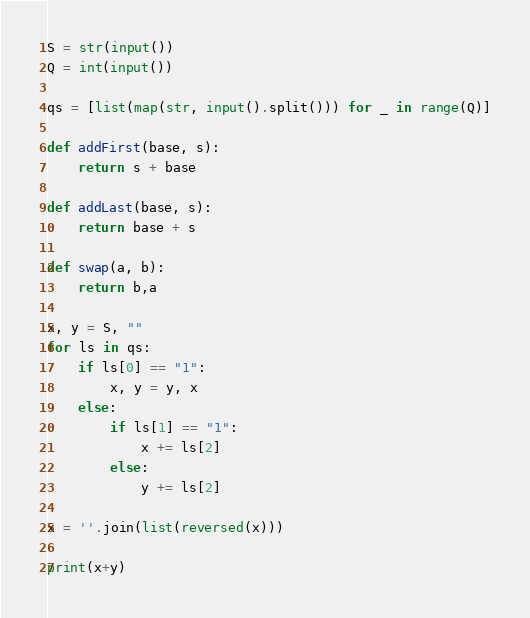<code> <loc_0><loc_0><loc_500><loc_500><_Python_>S = str(input())
Q = int(input())

qs = [list(map(str, input().split())) for _ in range(Q)]

def addFirst(base, s):
    return s + base

def addLast(base, s):
    return base + s

def swap(a, b):
    return b,a

x, y = S, ""
for ls in qs:
    if ls[0] == "1":
        x, y = y, x
    else:
        if ls[1] == "1":
            x += ls[2]
        else:
            y += ls[2]

x = ''.join(list(reversed(x)))

print(x+y)</code> 